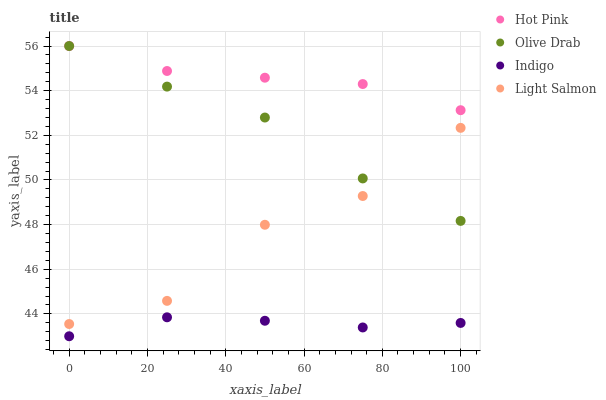Does Indigo have the minimum area under the curve?
Answer yes or no. Yes. Does Hot Pink have the maximum area under the curve?
Answer yes or no. Yes. Does Hot Pink have the minimum area under the curve?
Answer yes or no. No. Does Indigo have the maximum area under the curve?
Answer yes or no. No. Is Indigo the smoothest?
Answer yes or no. Yes. Is Light Salmon the roughest?
Answer yes or no. Yes. Is Hot Pink the smoothest?
Answer yes or no. No. Is Hot Pink the roughest?
Answer yes or no. No. Does Indigo have the lowest value?
Answer yes or no. Yes. Does Hot Pink have the lowest value?
Answer yes or no. No. Does Olive Drab have the highest value?
Answer yes or no. Yes. Does Indigo have the highest value?
Answer yes or no. No. Is Indigo less than Hot Pink?
Answer yes or no. Yes. Is Hot Pink greater than Indigo?
Answer yes or no. Yes. Does Hot Pink intersect Olive Drab?
Answer yes or no. Yes. Is Hot Pink less than Olive Drab?
Answer yes or no. No. Is Hot Pink greater than Olive Drab?
Answer yes or no. No. Does Indigo intersect Hot Pink?
Answer yes or no. No. 